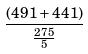Convert formula to latex. <formula><loc_0><loc_0><loc_500><loc_500>\frac { ( 4 9 1 + 4 4 1 ) } { \frac { 2 7 5 } { 5 } }</formula> 